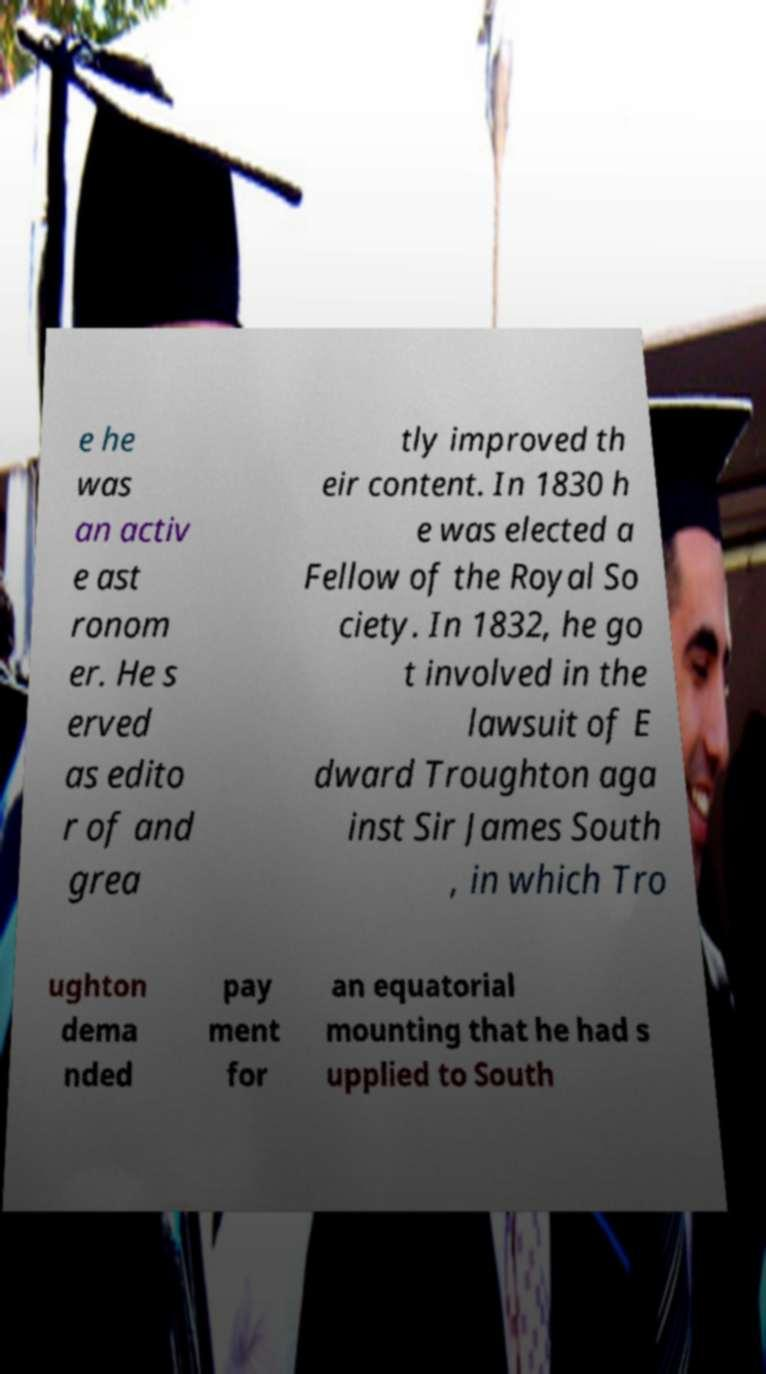What messages or text are displayed in this image? I need them in a readable, typed format. e he was an activ e ast ronom er. He s erved as edito r of and grea tly improved th eir content. In 1830 h e was elected a Fellow of the Royal So ciety. In 1832, he go t involved in the lawsuit of E dward Troughton aga inst Sir James South , in which Tro ughton dema nded pay ment for an equatorial mounting that he had s upplied to South 